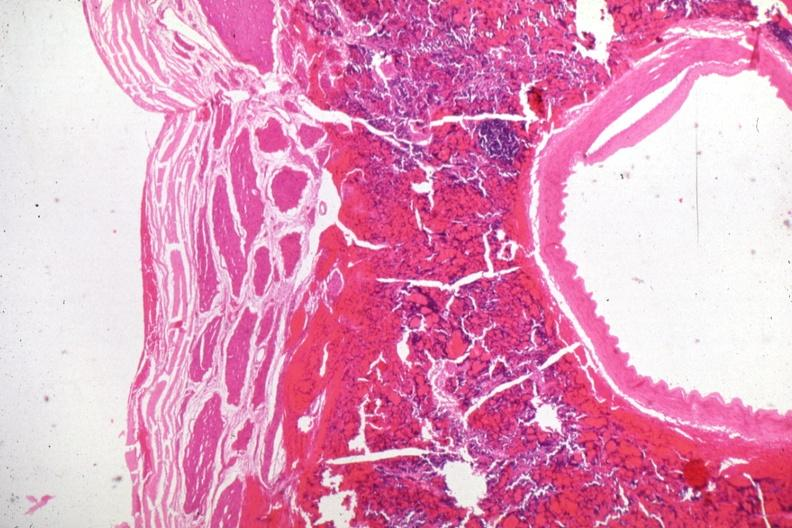what is present?
Answer the question using a single word or phrase. Endocrine 